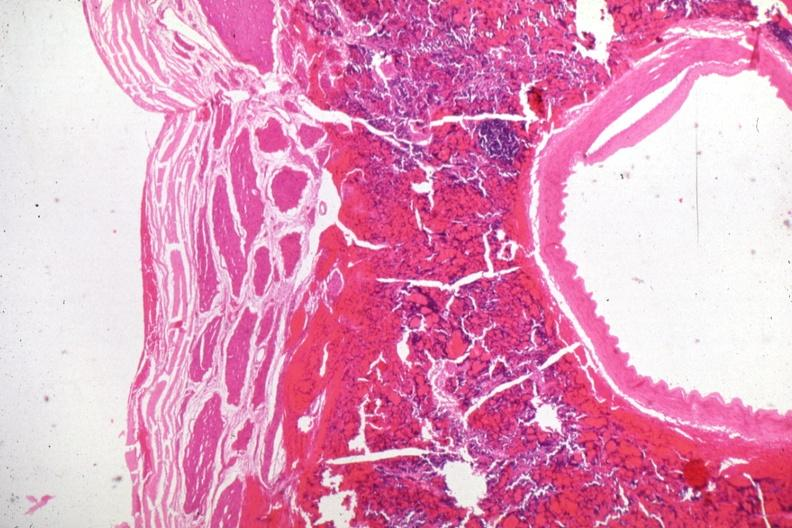what is present?
Answer the question using a single word or phrase. Endocrine 